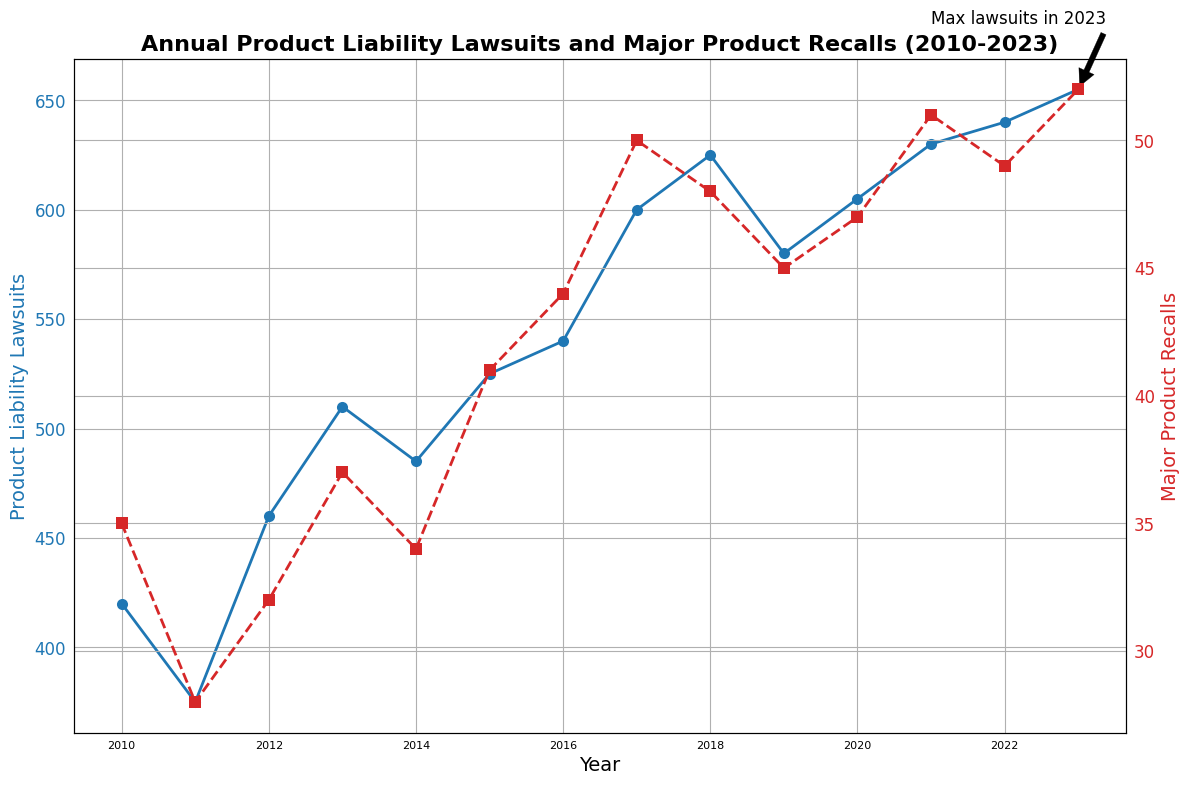What year had the highest number of product liability lawsuits? The annotation on the plot marks the year with the highest number of lawsuits. The annotation indicates that the highest number of lawsuits was in 2023.
Answer: 2023 Compare the number of major product recalls between 2010 and 2023. To compare, look at the values of major product recalls in 2010 and 2023. In 2010, there were 35 recalls, and in 2023, there were 52 recalls.
Answer: 52 > 35 By how much did product liability lawsuits increase from 2010 to 2023? To find the increase, subtract the number of lawsuits in 2010 from the number in 2023. In 2010, there were 420 lawsuits, and in 2023, there were 655 lawsuits. The increase is 655 - 420.
Answer: 235 What is the trend of product liability lawsuits from 2010 to 2023? The general trend can be observed by looking at the line representing lawsuits. The line shows a consistent upward trend from 2010 to 2023.
Answer: Upward trend Are there any years where major product recalls decreased compared to the previous year? Compare the values of major product recalls year by year. Recall values decreased from 2017 (50) to 2018 (48), and from 2021 (51) to 2022 (49).
Answer: Yes, in 2018 and 2022 Compare the rate of increase in product liability lawsuits and major product recalls from 2010 to 2023. Calculate the rate of increase for both lawsuits and recalls. Lawsuits increased from 420 to 655 (an increase of 235), and recalls increased from 35 to 52 (an increase of 17). The rate of increase is higher for lawsuits compared to recalls.
Answer: Lawsuits increased at a higher rate During which year(s) did both product liability lawsuits and major product recalls increase from the previous year? Check year-by-year increases for both variables. Both lawsuits and recalls increased in most years, exceptions include 2018 (lawsuits up, recalls down), 2019 (lawsuits down, recalls up), and 2022 (lawsuits up, recalls down).
Answer: Most years except 2018, 2019, and 2022 What is the average number of product liability lawsuits from 2010 to 2023? Sum the number of lawsuits from 2010 to 2023 and divide by the number of years (14 years). Sum: 420 + 375 + 460 + 510 + 485 + 525 + 540 + 600 + 625 + 580 + 605 + 630 + 640 + 655 = 8250. Average = 8250 / 14.
Answer: 589 